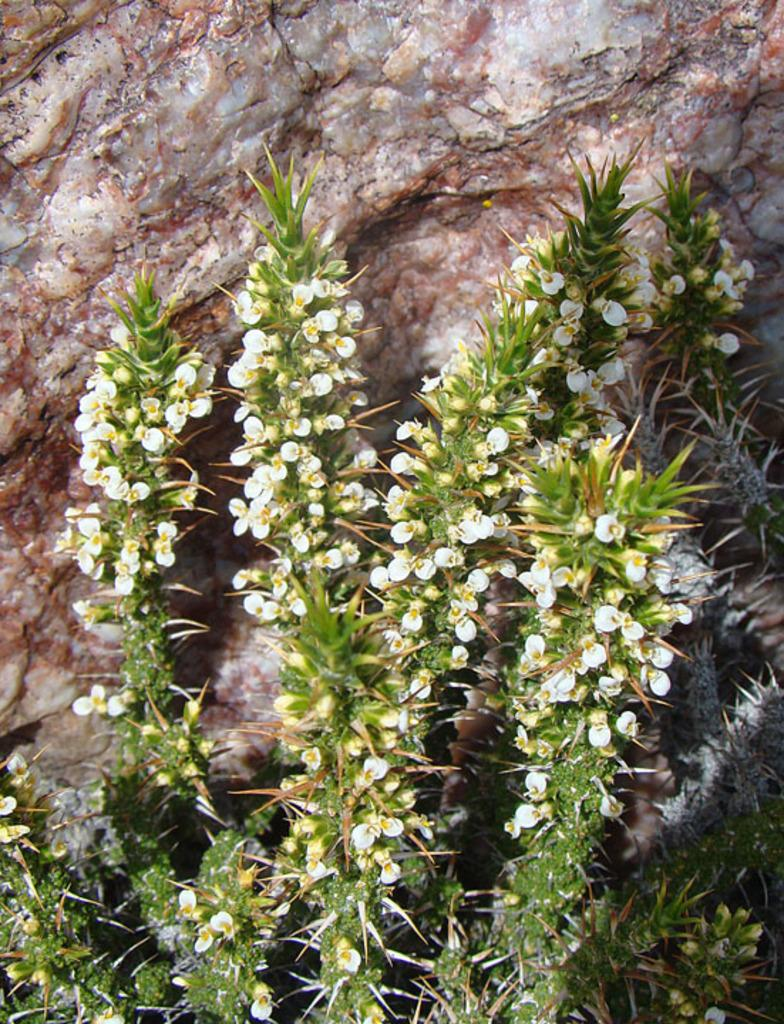What type of plants can be seen in the image? There are flower plants in the image. Where are the flower plants located? The flower plants are present over a place. What other object can be seen in the image? There is a rock stone visible in the image. How much sugar is present in the rock stone in the image? There is no sugar present in the rock stone in the image, as it is a natural object and not associated with sugar. 